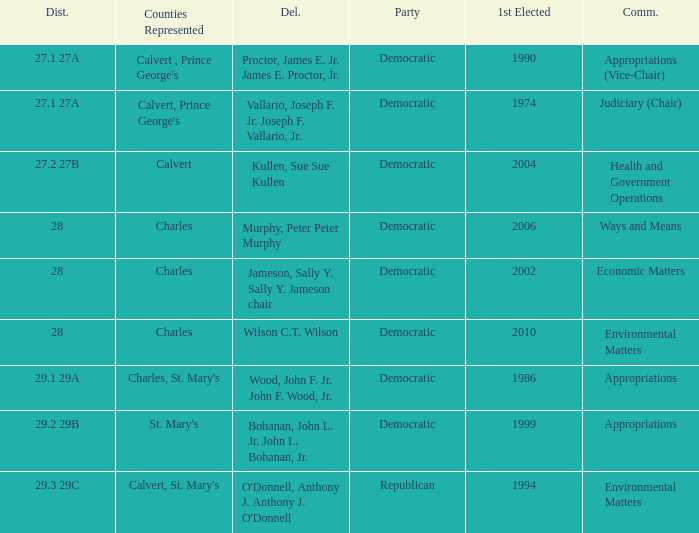When first elected was 2006, who was the delegate? Murphy, Peter Peter Murphy. 